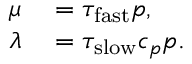Convert formula to latex. <formula><loc_0><loc_0><loc_500><loc_500>\begin{array} { r l } { \mu } & = \tau _ { f a s t } p , } \\ { \lambda } & = \tau _ { s l o w } c _ { p } p . } \end{array}</formula> 